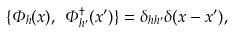<formula> <loc_0><loc_0><loc_500><loc_500>\{ \Phi _ { h } ( x ) , \ \Phi _ { h ^ { \prime } } ^ { \dagger } ( x ^ { \prime } ) \} = \delta _ { h h ^ { \prime } } \delta ( x - x ^ { \prime } ) ,</formula> 